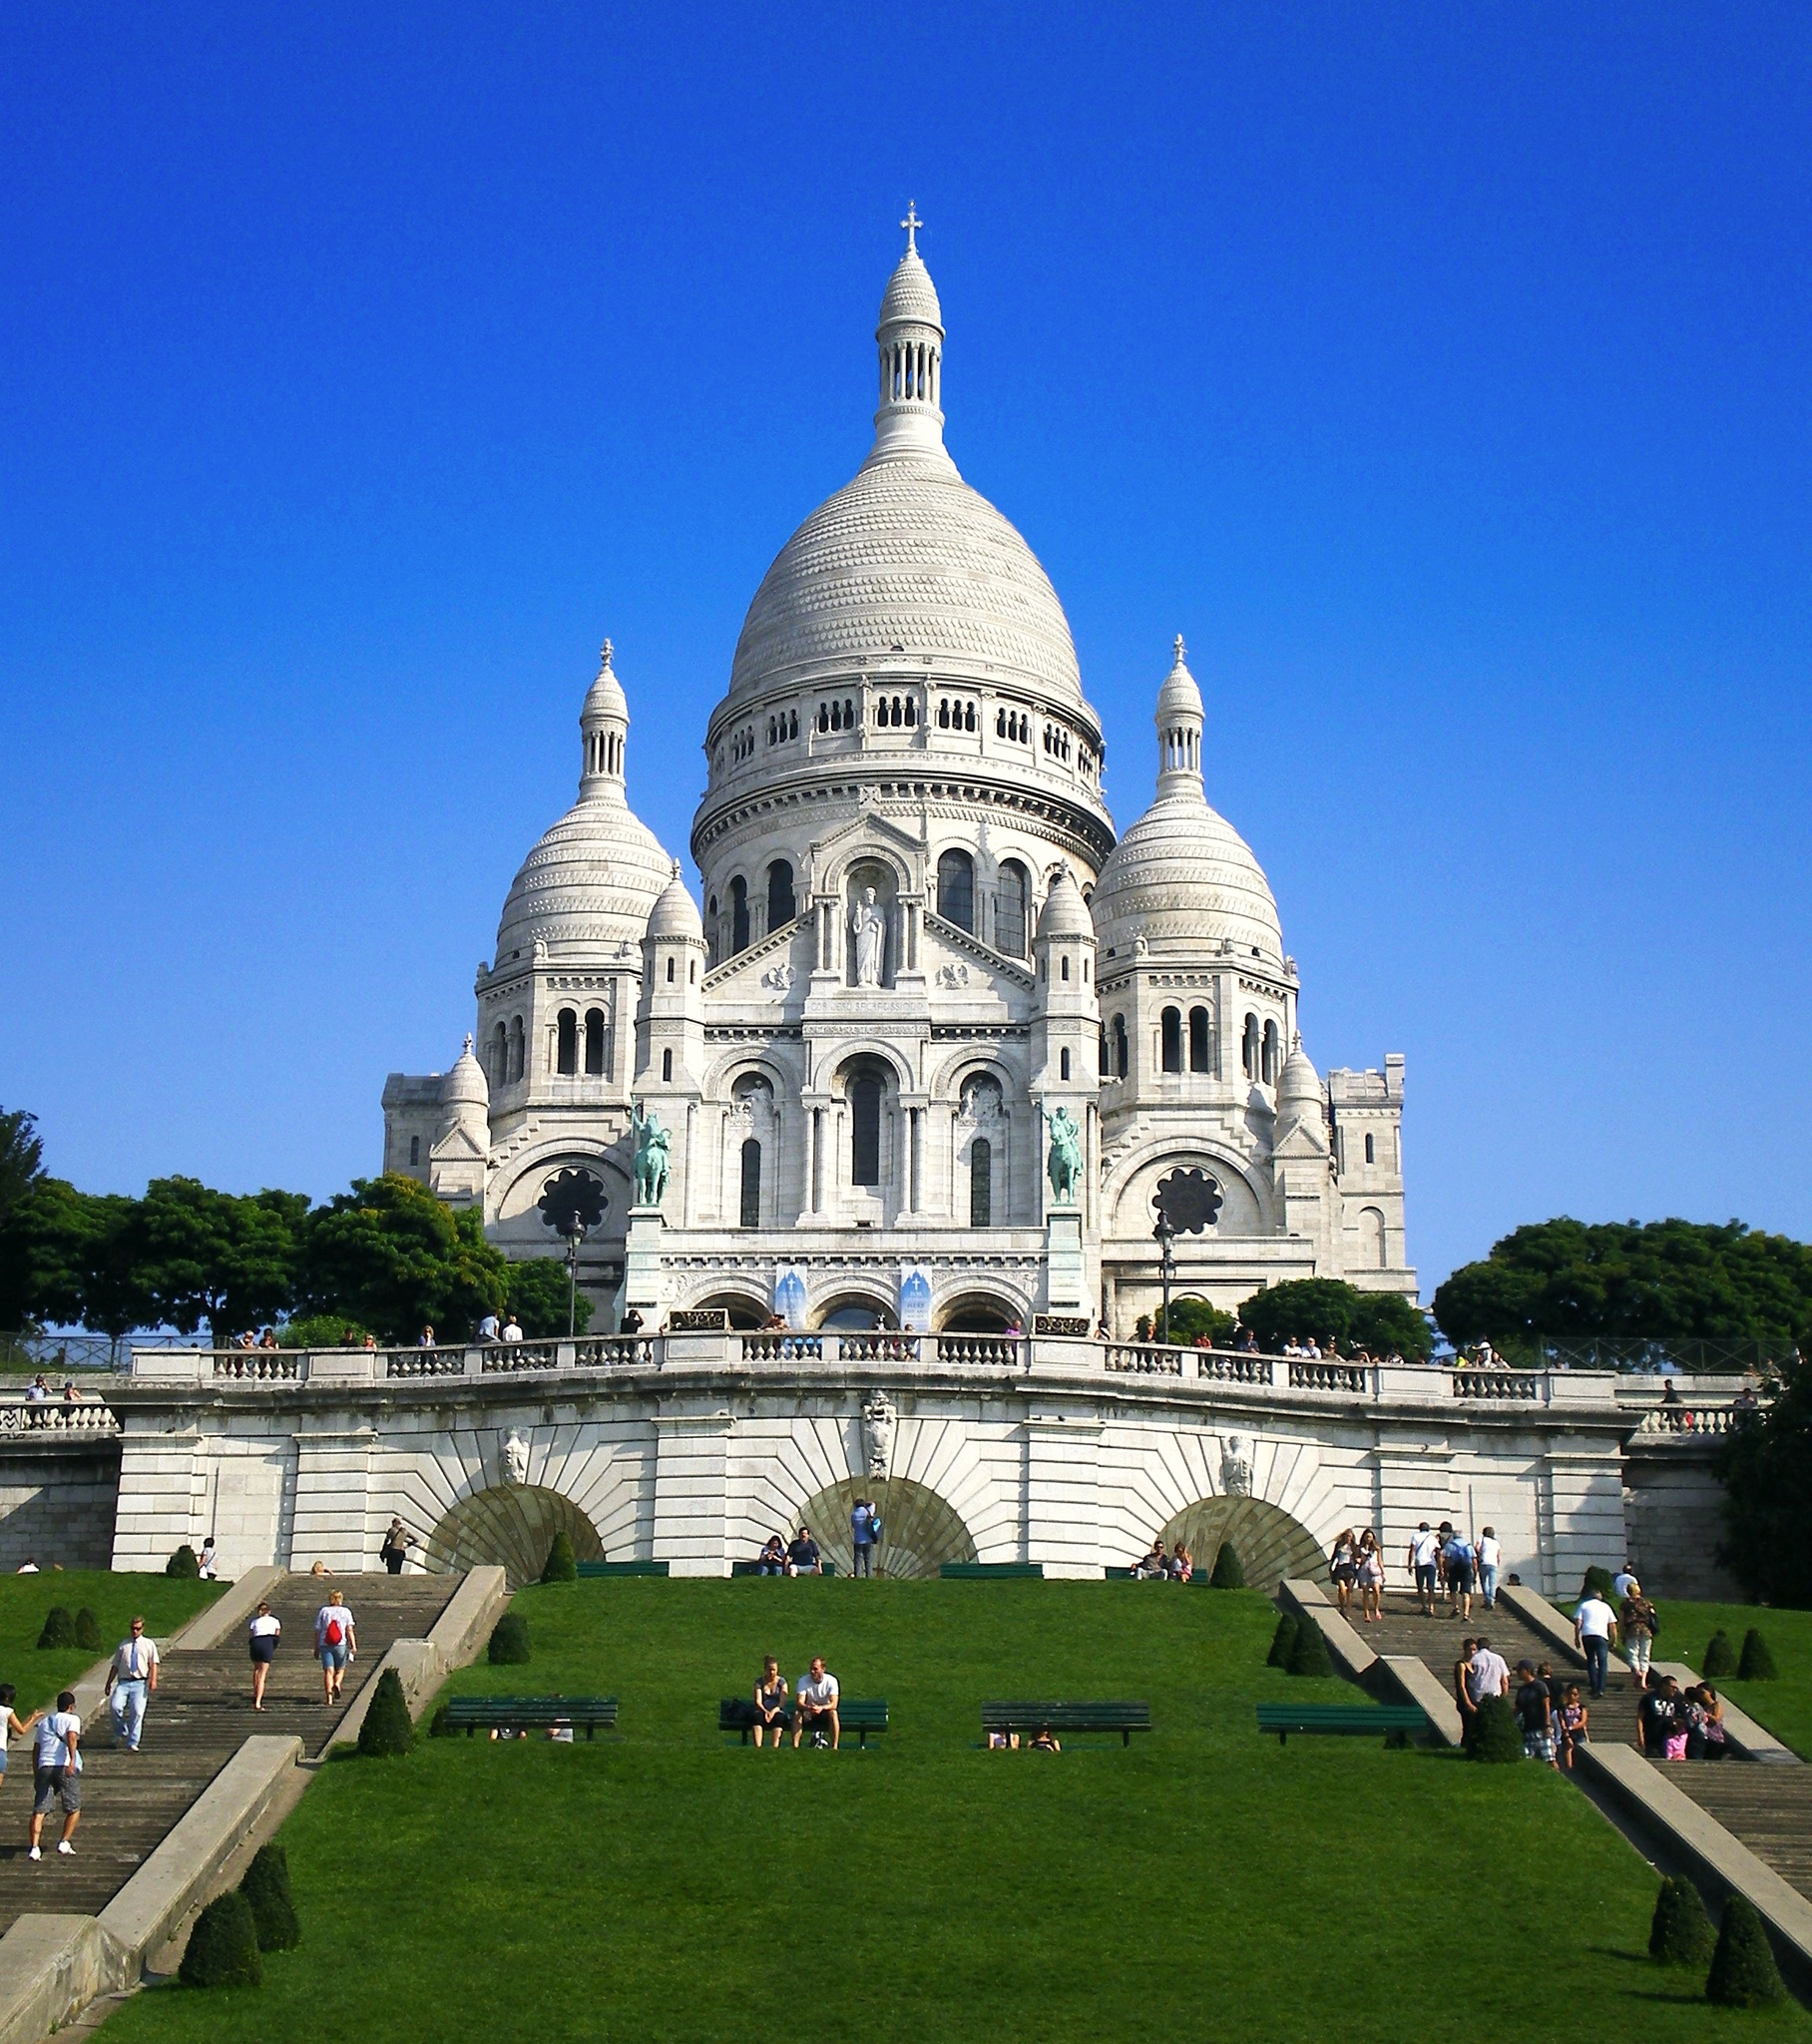Can you describe the main features of this image for me? The image captures the majestic Sacré Coeur, a renowned Roman Catholic church and minor basilica, nestled in the heart of Paris, France. The church, painted in hues of white, stands out against the backdrop of a clear sky, its color a brilliant blue. The structure of the church is fully visible, showcasing its grandeur and architectural beauty. The large dome on top of the church is a prominent feature, adding to its imposing presence. 

The perspective of the photo suggests it was taken from a distance, allowing for a comprehensive view of the church and its surroundings. The area around the church is bustling with life, with people seen walking around and others sitting leisurely on the grass in front of the church, soaking in the serene atmosphere. The image encapsulates not just the physical structure of the Sacré Coeur, but also the lively and vibrant ambiance that surrounds this iconic landmark. 